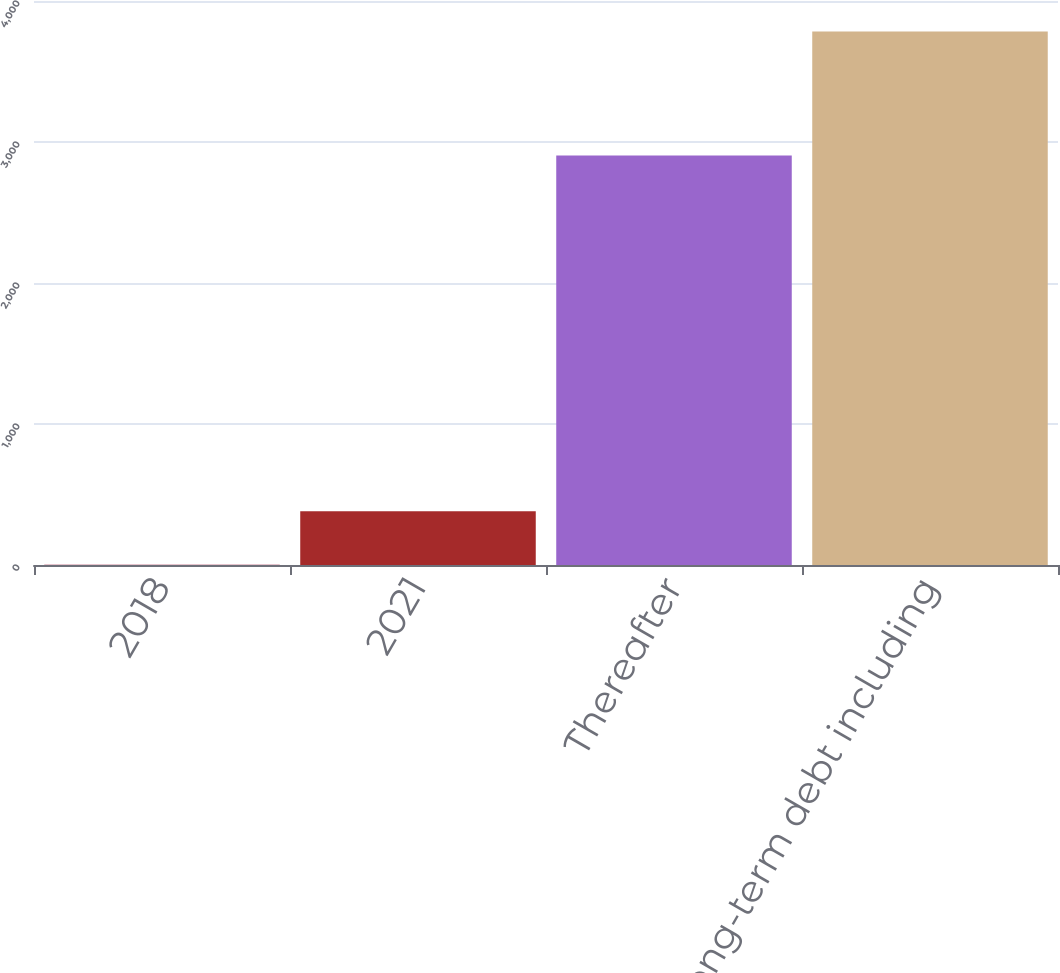Convert chart. <chart><loc_0><loc_0><loc_500><loc_500><bar_chart><fcel>2018<fcel>2021<fcel>Thereafter<fcel>Total long-term debt including<nl><fcel>3<fcel>381<fcel>2905<fcel>3783<nl></chart> 